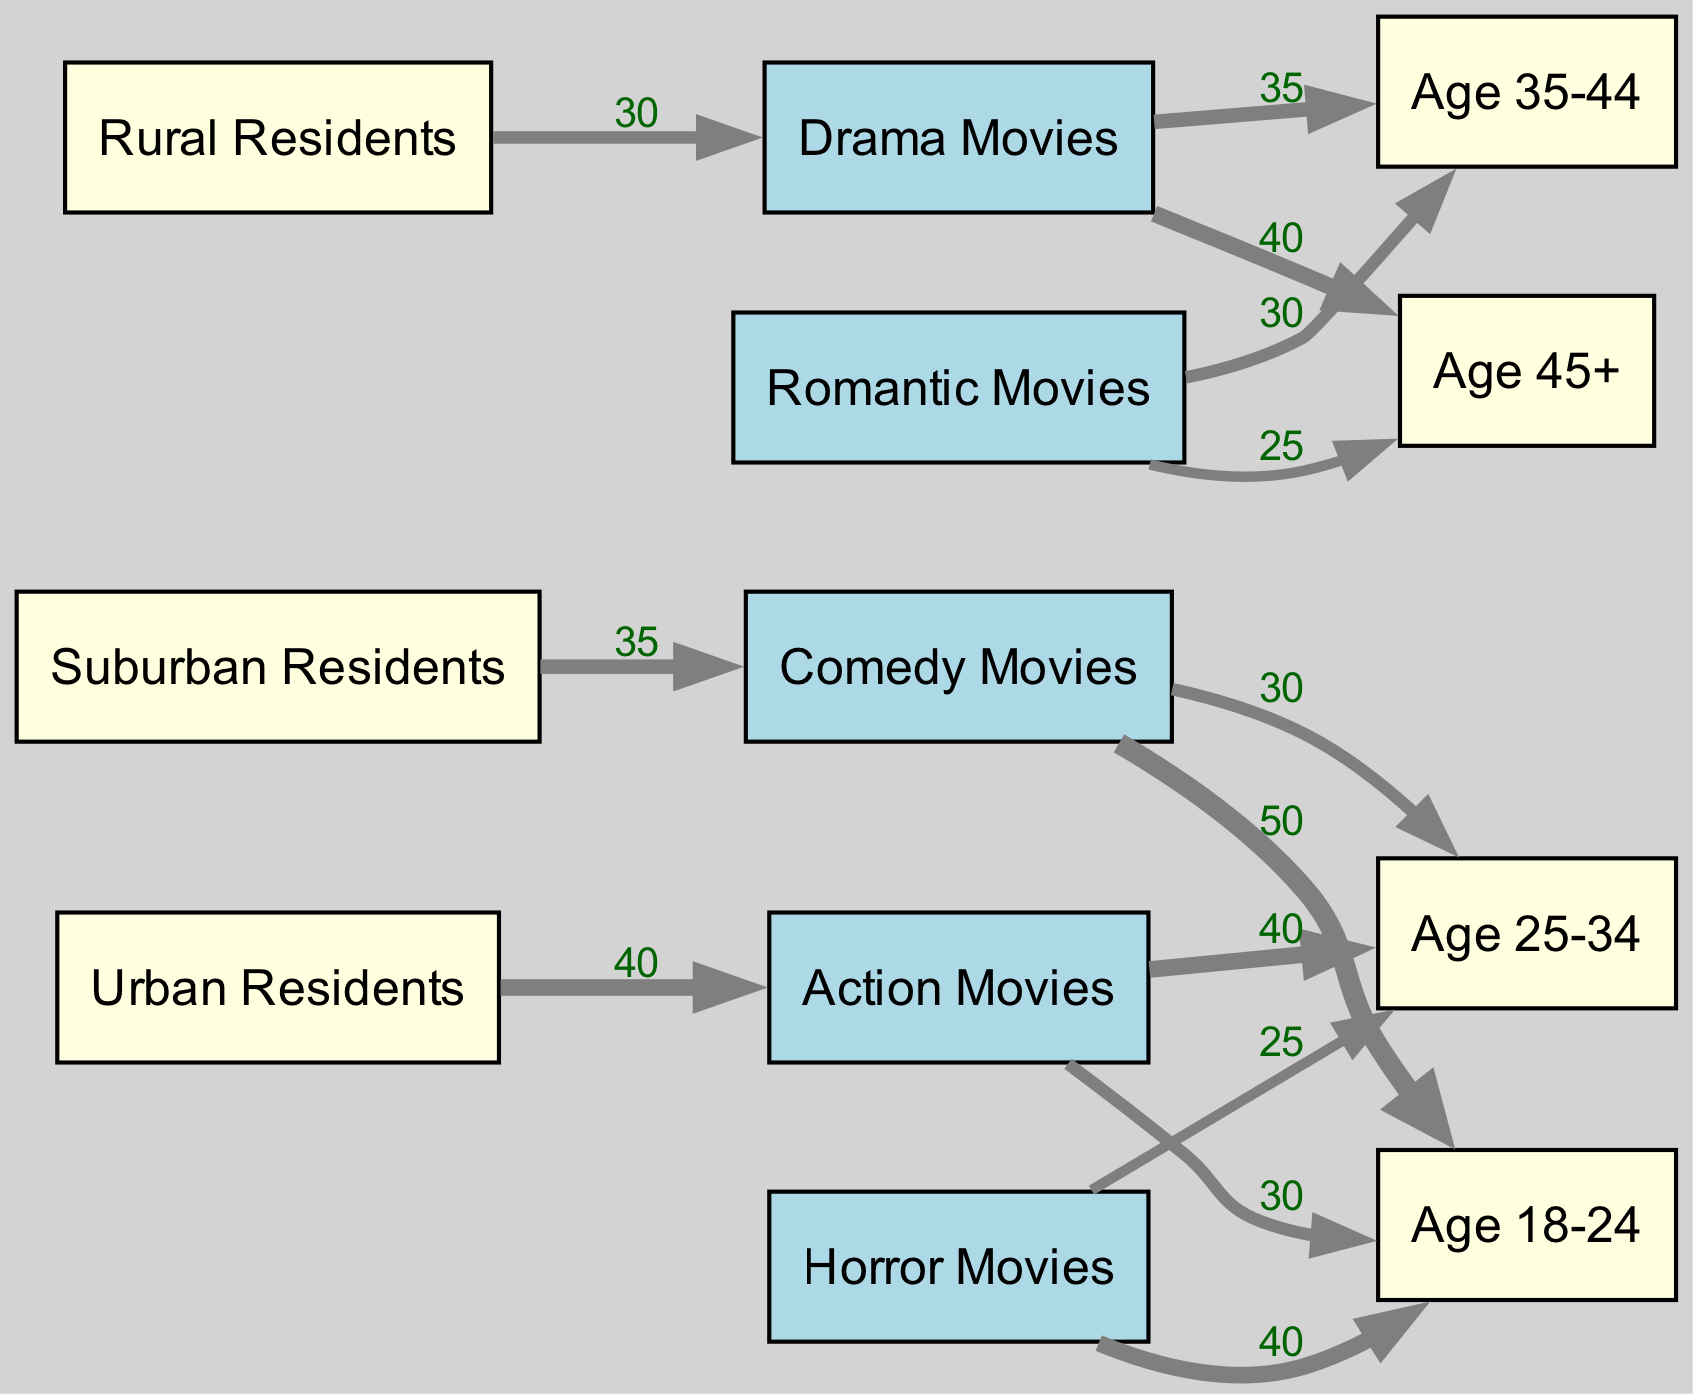What age group shows the highest preference for Action Movies? By examining the links connected to "Action Movies," we see they connect to "Age 18-24" with a value of 30 and to "Age 25-34" with a value of 40. The higher value indicates that "Age 25-34" has the highest preference for Action Movies.
Answer: Age 25-34 Which genre is most popular among Urban Residents? The link between "Urban Residents" and "Action Movies" has the highest value of 40, indicating that Urban Residents prefer Action Movies the most compared to the other genres.
Answer: Action Movies What is the total number of genres represented in the diagram? The diagram includes six nodes categorized under "Genre": Action Movies, Comedy Movies, Drama Movies, Horror Movies, and Romantic Movies. Counting these, we find the total is six.
Answer: 6 How many links are associated with Comedy Movies? The links for "Comedy Movies" connect to "Age 18-24" (value 50) and "Age 25-34" (value 30), which totals to two links originating from this genre.
Answer: 2 Which demographic shows the highest preference for Horror Movies? The flow leading from "Horror Movies" shows links to "Age 18-24" with a value of 40 and "Age 25-34" with a value of 25. Comparing these values, "Age 18-24" has the higher preference for Horror Movies.
Answer: Age 18-24 What is the value of links from Drama Movies to Age 45+? The link from "Drama Movies" to "Age 45+" is directly indicated with a value of 40. Therefore, 40 is the value for this specific link.
Answer: 40 Which demographic has the lowest connection to romantic movies? The links for "Romantic Movies" lead to "Age 35-44" (value 30) and "Age 45+" (value 25). Among these, "Age 45+" has the lowest connection to Romantic Movies.
Answer: Age 45+ What genre is preferred by the majority of Age 18-24 viewers? Analyzing links to "Age 18-24," they connect with Action Movies (value 30), Comedy Movies (value 50), and Horror Movies (value 40). The value for Comedy Movies is the highest at 50, indicating it is the preferred genre for this age group.
Answer: Comedy Movies How many total connections (links) are there in the diagram? To find the total connections, we count each link listed in the "links" section: there are eight connections.
Answer: 8 